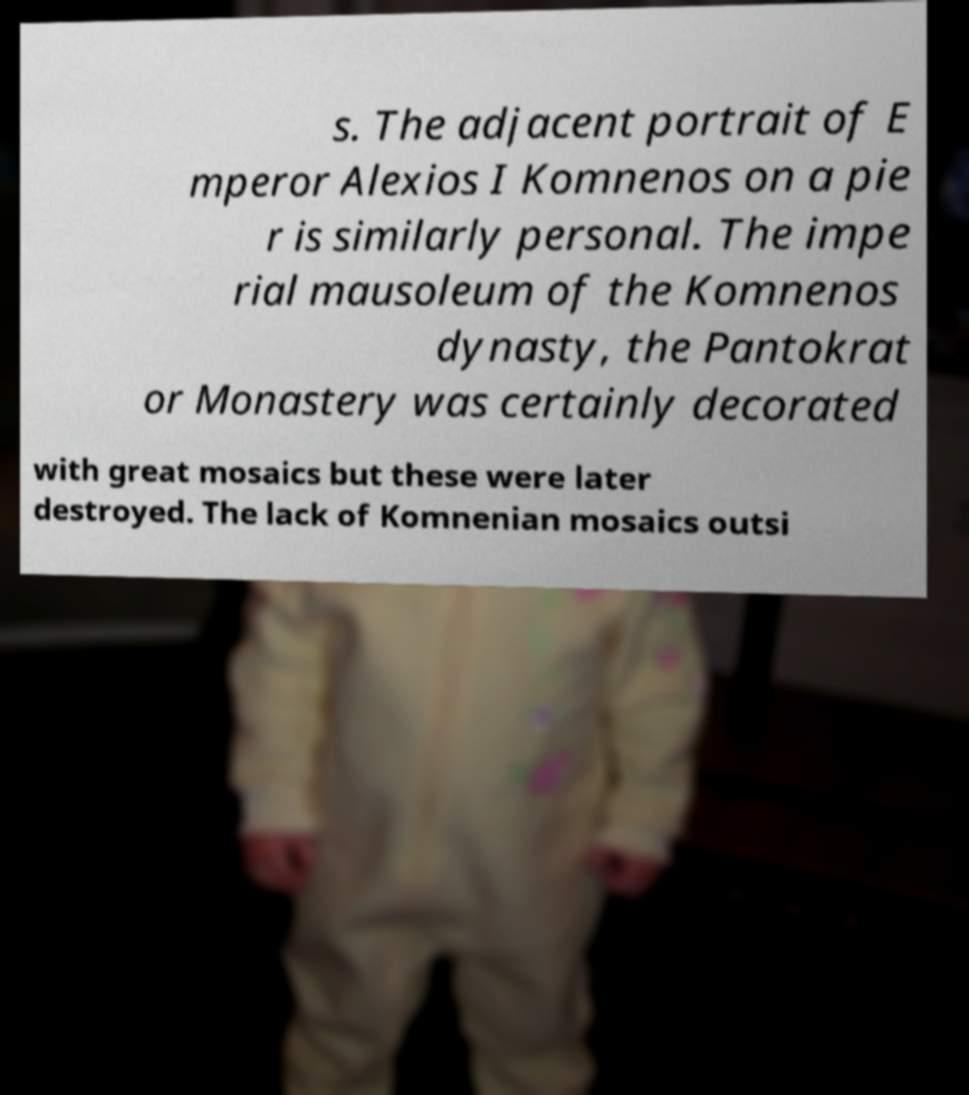Please identify and transcribe the text found in this image. s. The adjacent portrait of E mperor Alexios I Komnenos on a pie r is similarly personal. The impe rial mausoleum of the Komnenos dynasty, the Pantokrat or Monastery was certainly decorated with great mosaics but these were later destroyed. The lack of Komnenian mosaics outsi 